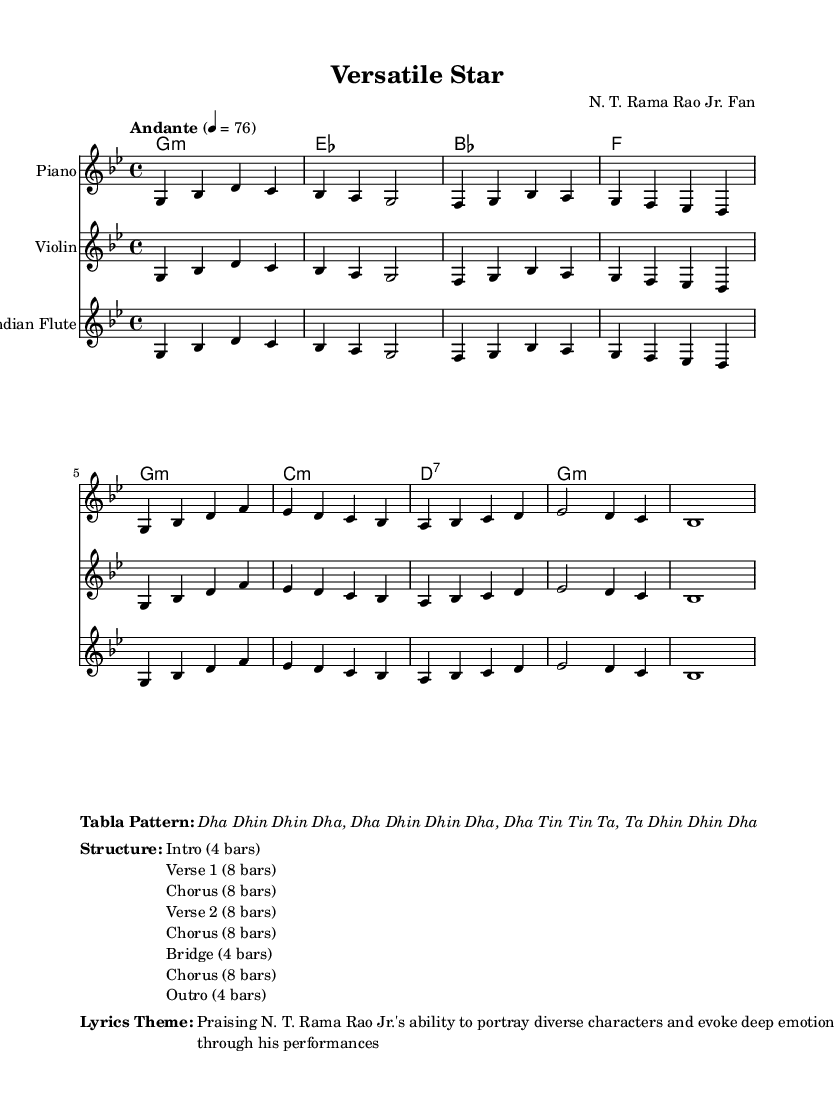What is the key signature of this music? The key signature is G minor, which has two flats (B flat and E flat).
Answer: G minor What is the time signature of this music? The time signature is indicated as 4/4, which means there are four beats in each measure and the quarter note receives one beat.
Answer: 4/4 What is the tempo marking of this piece? The tempo marking indicates "Andante," which suggests a moderately slow pace, typically around 76 beats per minute.
Answer: Andante How many bars are in the Intro section? The structure shows that the Intro section consists of 4 bars as stated at the beginning of the structure layout.
Answer: 4 bars Which instrument types are indicated in the score? The score shows the use of Piano, Violin, and Indian Flute, as listed under the instrument names in each respective staff.
Answer: Piano, Violin, Indian Flute What chords are used in the Chorus section? The Chorus section utilizes the chords: G minor, B flat, and F as specified in the harmonies section.
Answer: G minor, B flat, F What is the central theme of the lyrics? The lyrics theme describes praising N. T. Rama Rao Jr.'s versatility and emotional portrayal in his performances, emphasizing his talent in different roles.
Answer: Praising N. T. Rama Rao Jr.'s ability to portray diverse characters 